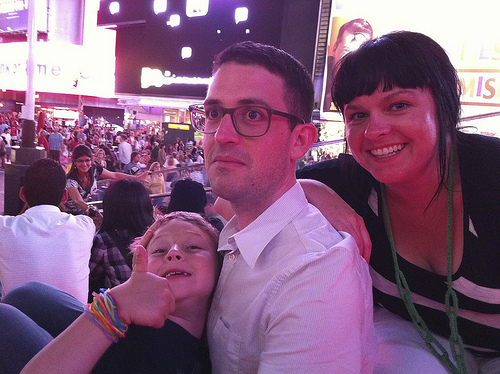<image>
Is the man behind the woman? No. The man is not behind the woman. From this viewpoint, the man appears to be positioned elsewhere in the scene. Is there a kid next to the man? Yes. The kid is positioned adjacent to the man, located nearby in the same general area. 